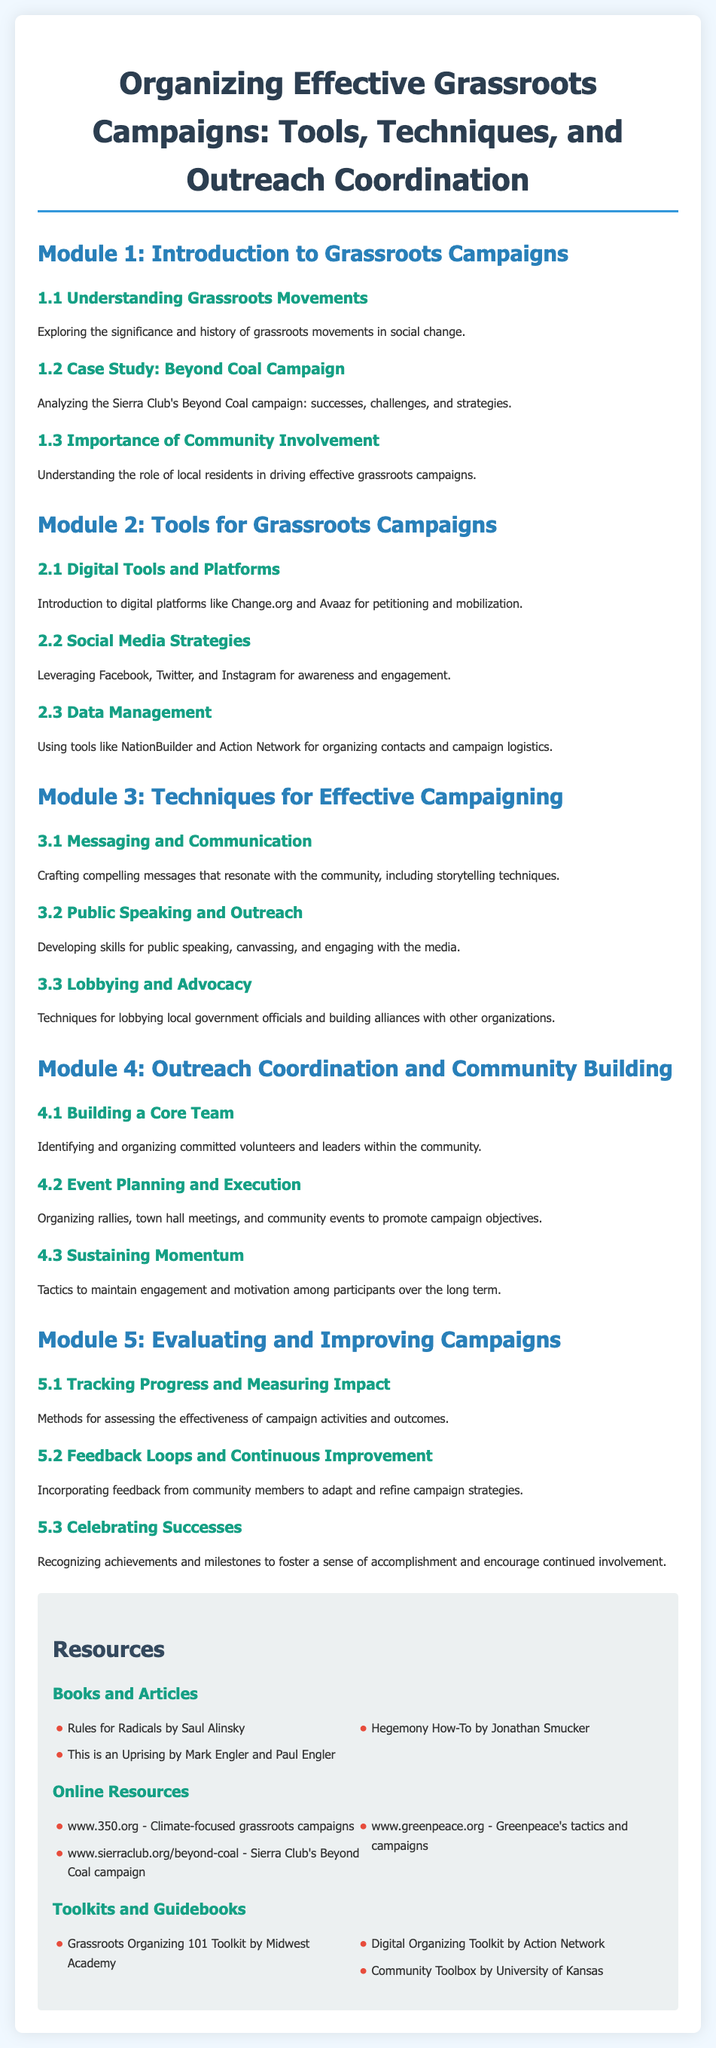what is the title of the syllabus? The title is prominently displayed at the top of the document, indicating the focus on grassroots campaigns.
Answer: Organizing Effective Grassroots Campaigns: Tools, Techniques, and Outreach Coordination what is the first module in the syllabus? The first module is listed in a clear format and introduces the foundational concepts related to grassroots campaigns.
Answer: Introduction to Grassroots Campaigns what is the case study highlighted in Module 1? The case study is mentioned under the first module, showcasing a specific campaign for analysis.
Answer: Beyond Coal Campaign which social media platforms are mentioned in Module 2? The platforms are specified under social media strategies, emphasizing their importance for engagement.
Answer: Facebook, Twitter, and Instagram how many techniques for effective campaigning are outlined in Module 3? The number of techniques is indicated in the module title and content, illustrating the instructional focus.
Answer: Three what is the purpose of tracking progress in Module 5? The purpose is explained in the context of assessing and measuring campaign effectiveness and outcomes.
Answer: Assessing effectiveness which toolkit is recommended under the Toolkits and Guidebooks section? The title of the recommended toolkit is presented as a resource for grassroots organizers.
Answer: Grassroots Organizing 101 Toolkit by Midwest Academy what is the color scheme of the document's header? The header's color scheme is described in the document's styling, which creates a specific visual impact.
Answer: Blue and gray what is the role of local residents according to Module 1? The role is defined in terms of their significance in contributing to grassroots movements as outlined in the syllabus.
Answer: Driving effective grassroots campaigns 